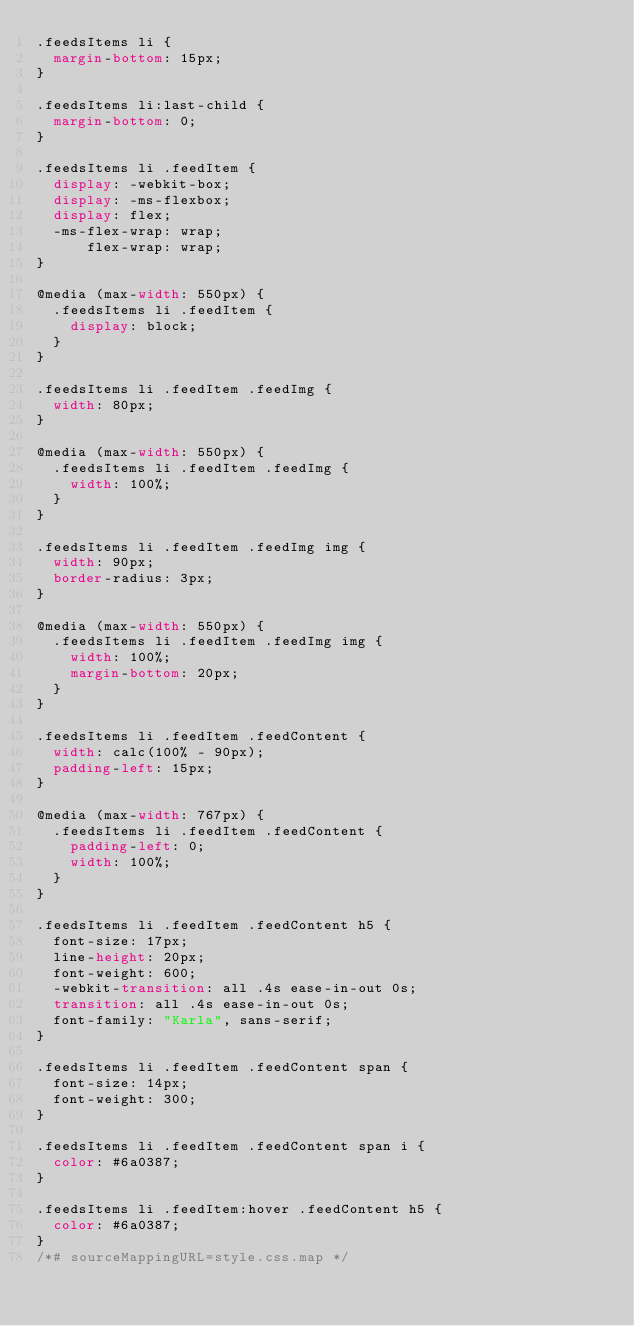Convert code to text. <code><loc_0><loc_0><loc_500><loc_500><_CSS_>.feedsItems li {
  margin-bottom: 15px;
}

.feedsItems li:last-child {
  margin-bottom: 0;
}

.feedsItems li .feedItem {
  display: -webkit-box;
  display: -ms-flexbox;
  display: flex;
  -ms-flex-wrap: wrap;
      flex-wrap: wrap;
}

@media (max-width: 550px) {
  .feedsItems li .feedItem {
    display: block;
  }
}

.feedsItems li .feedItem .feedImg {
  width: 80px;
}

@media (max-width: 550px) {
  .feedsItems li .feedItem .feedImg {
    width: 100%;
  }
}

.feedsItems li .feedItem .feedImg img {
  width: 90px;
  border-radius: 3px;
}

@media (max-width: 550px) {
  .feedsItems li .feedItem .feedImg img {
    width: 100%;
    margin-bottom: 20px;
  }
}

.feedsItems li .feedItem .feedContent {
  width: calc(100% - 90px);
  padding-left: 15px;
}

@media (max-width: 767px) {
  .feedsItems li .feedItem .feedContent {
    padding-left: 0;
    width: 100%;
  }
}

.feedsItems li .feedItem .feedContent h5 {
  font-size: 17px;
  line-height: 20px;
  font-weight: 600;
  -webkit-transition: all .4s ease-in-out 0s;
  transition: all .4s ease-in-out 0s;
  font-family: "Karla", sans-serif;
}

.feedsItems li .feedItem .feedContent span {
  font-size: 14px;
  font-weight: 300;
}

.feedsItems li .feedItem .feedContent span i {
  color: #6a0387;
}

.feedsItems li .feedItem:hover .feedContent h5 {
  color: #6a0387;
}
/*# sourceMappingURL=style.css.map */</code> 